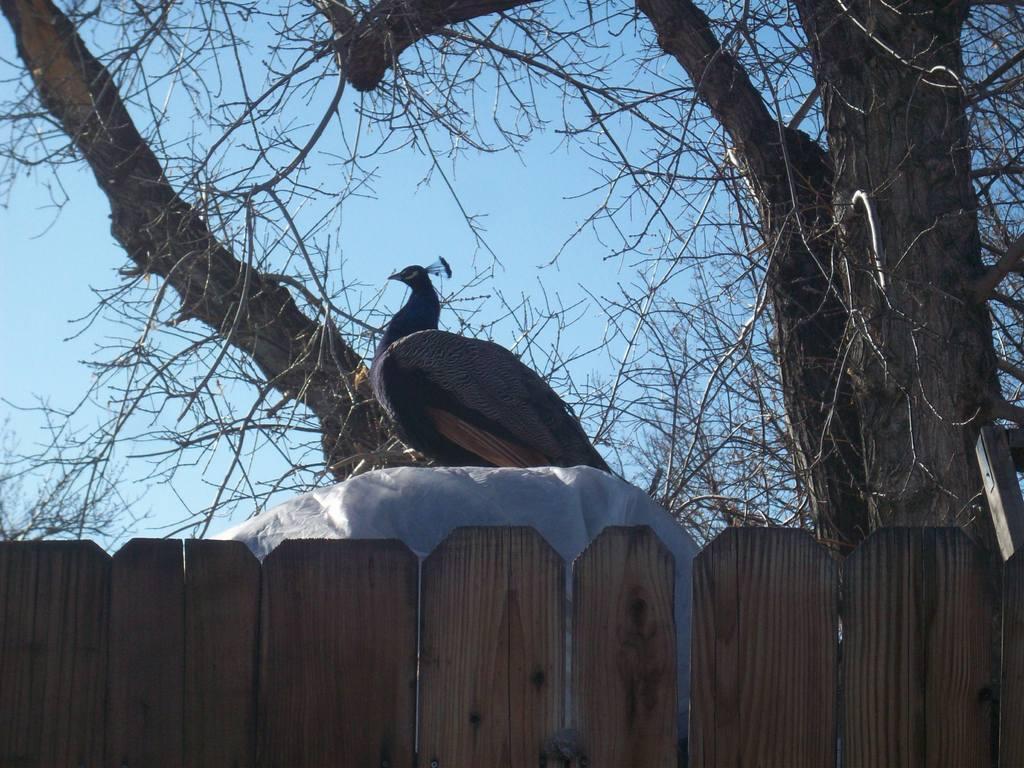Could you give a brief overview of what you see in this image? In this picture we can see a peacock, wooden fence, trees and in the background we can see the sky. 